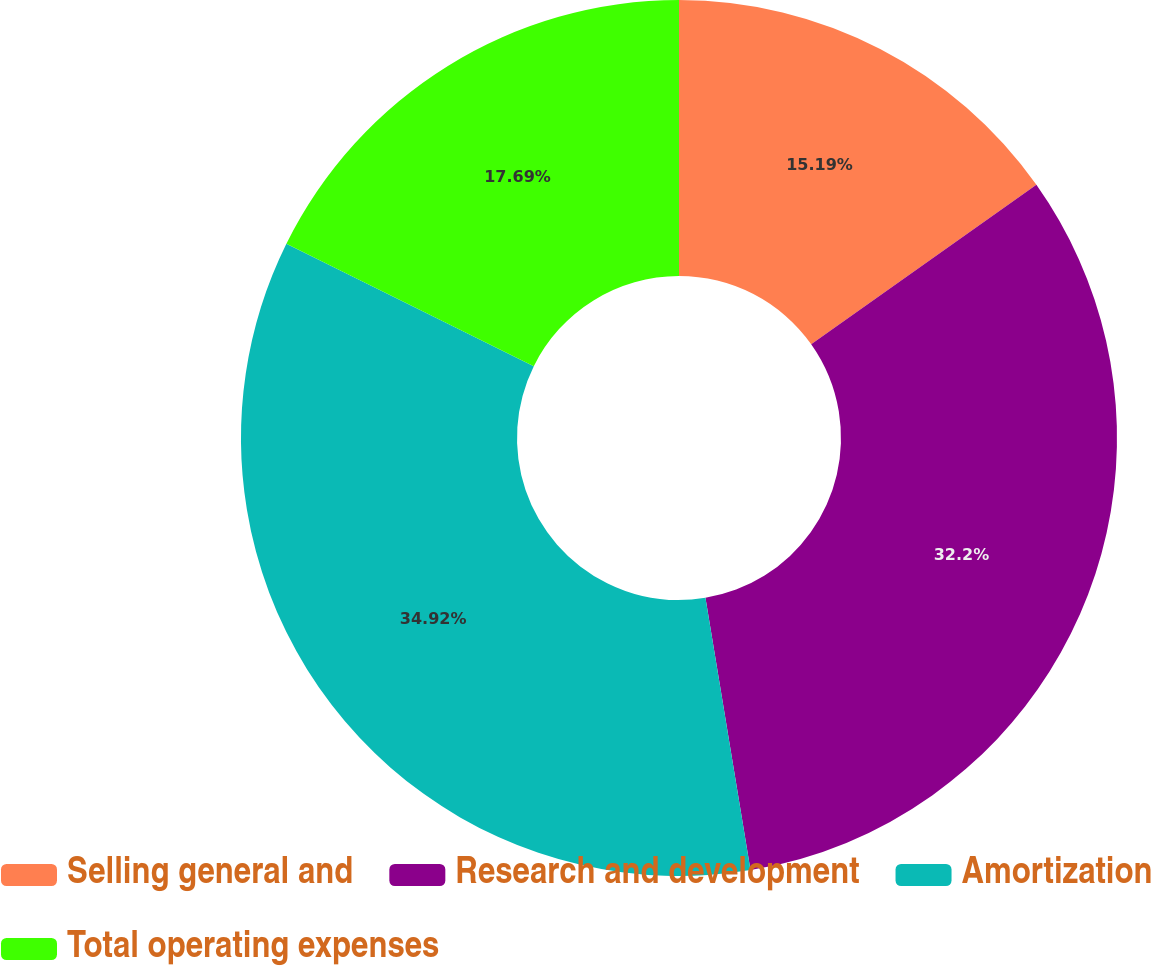Convert chart. <chart><loc_0><loc_0><loc_500><loc_500><pie_chart><fcel>Selling general and<fcel>Research and development<fcel>Amortization<fcel>Total operating expenses<nl><fcel>15.19%<fcel>32.2%<fcel>34.92%<fcel>17.69%<nl></chart> 